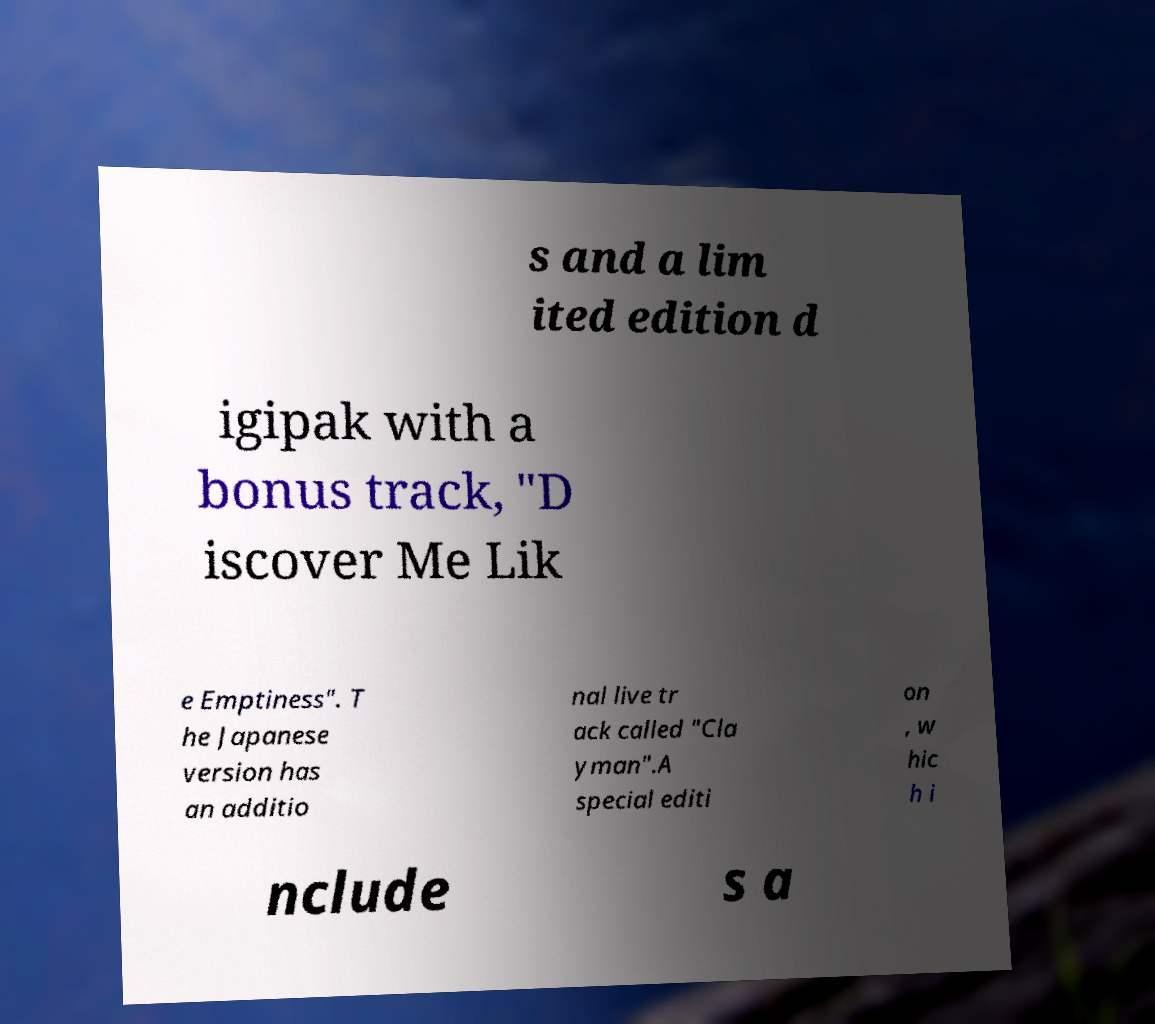Could you assist in decoding the text presented in this image and type it out clearly? s and a lim ited edition d igipak with a bonus track, "D iscover Me Lik e Emptiness". T he Japanese version has an additio nal live tr ack called "Cla yman".A special editi on , w hic h i nclude s a 